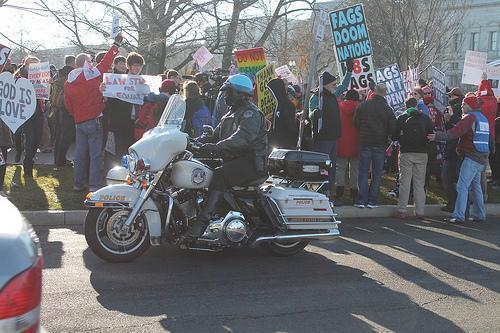How many rainbow signs are there?
Give a very brief answer. 1. 